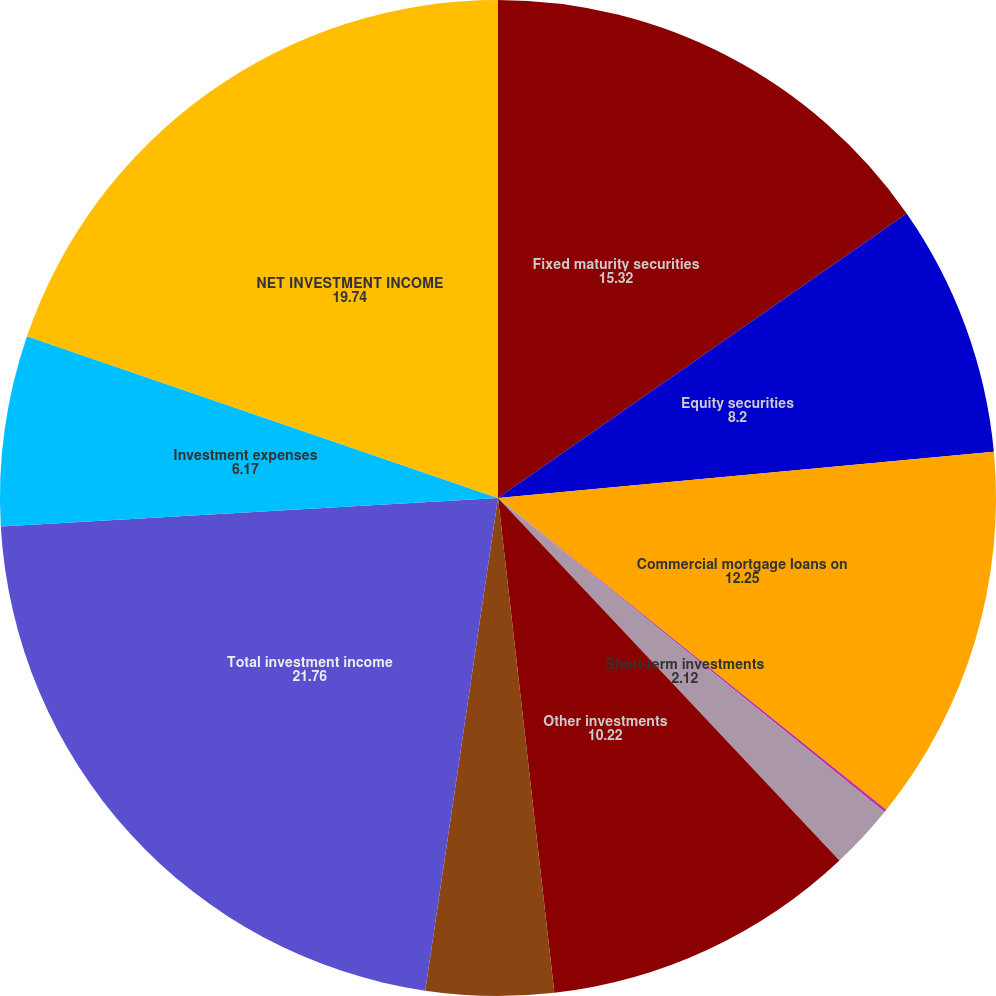<chart> <loc_0><loc_0><loc_500><loc_500><pie_chart><fcel>Fixed maturity securities<fcel>Equity securities<fcel>Commercial mortgage loans on<fcel>Policy loans<fcel>Short-term investments<fcel>Other investments<fcel>Cash and cash equivalents<fcel>Total investment income<fcel>Investment expenses<fcel>NET INVESTMENT INCOME<nl><fcel>15.32%<fcel>8.2%<fcel>12.25%<fcel>0.09%<fcel>2.12%<fcel>10.22%<fcel>4.14%<fcel>21.76%<fcel>6.17%<fcel>19.74%<nl></chart> 